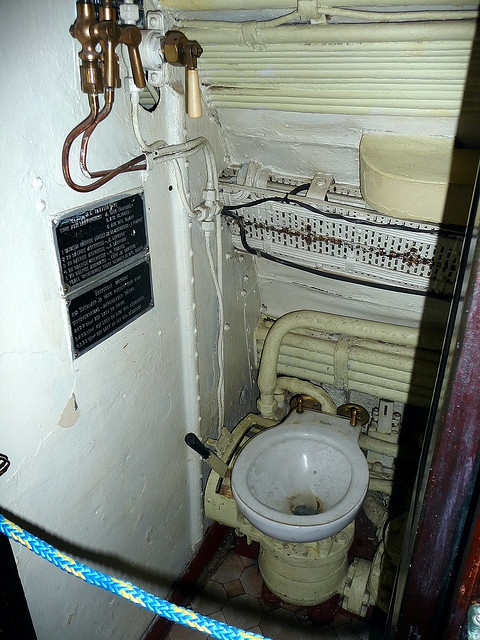Describe the objects in this image and their specific colors. I can see a toilet in gray, darkgray, and black tones in this image. 